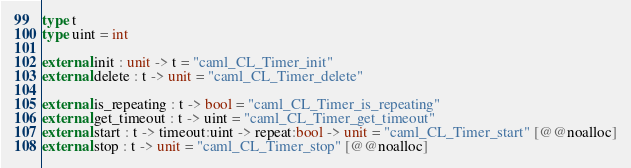Convert code to text. <code><loc_0><loc_0><loc_500><loc_500><_OCaml_>type t
type uint = int

external init : unit -> t = "caml_CL_Timer_init"
external delete : t -> unit = "caml_CL_Timer_delete"

external is_repeating : t -> bool = "caml_CL_Timer_is_repeating"
external get_timeout : t -> uint = "caml_CL_Timer_get_timeout"
external start : t -> timeout:uint -> repeat:bool -> unit = "caml_CL_Timer_start" [@@noalloc]
external stop : t -> unit = "caml_CL_Timer_stop" [@@noalloc]
</code> 